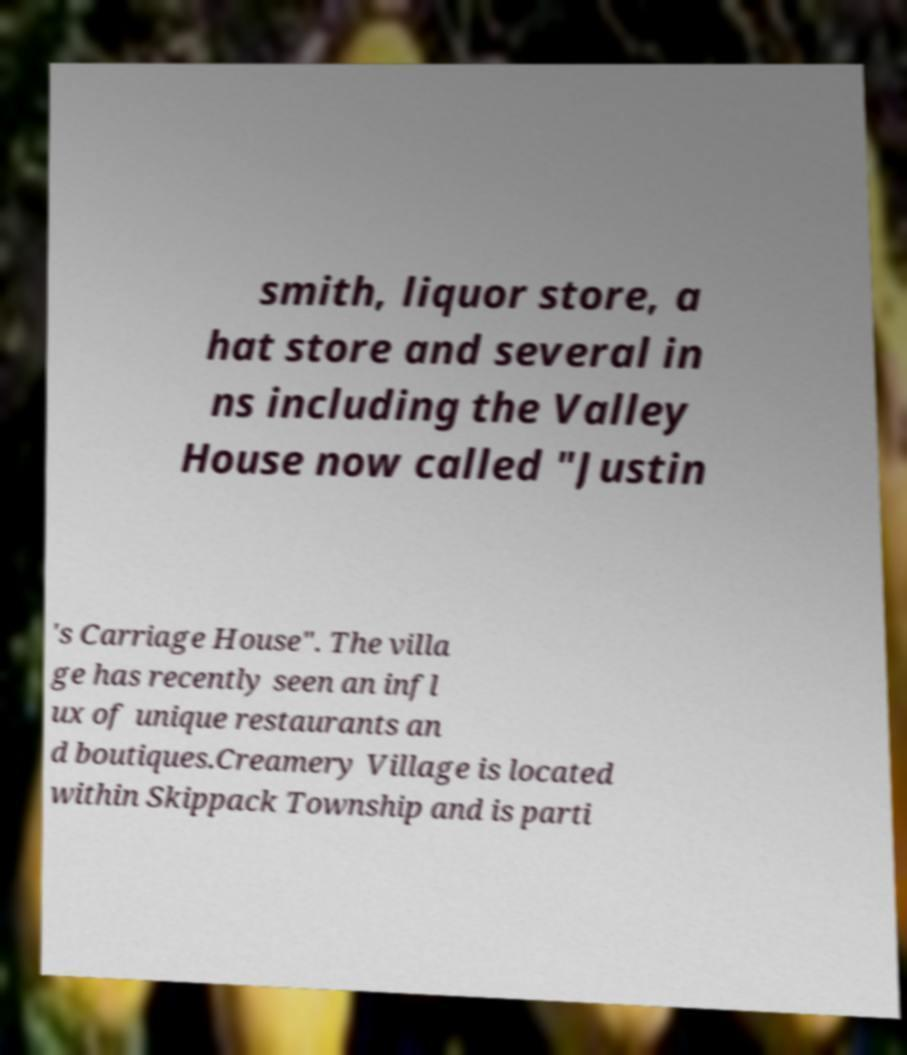Please identify and transcribe the text found in this image. smith, liquor store, a hat store and several in ns including the Valley House now called "Justin 's Carriage House". The villa ge has recently seen an infl ux of unique restaurants an d boutiques.Creamery Village is located within Skippack Township and is parti 